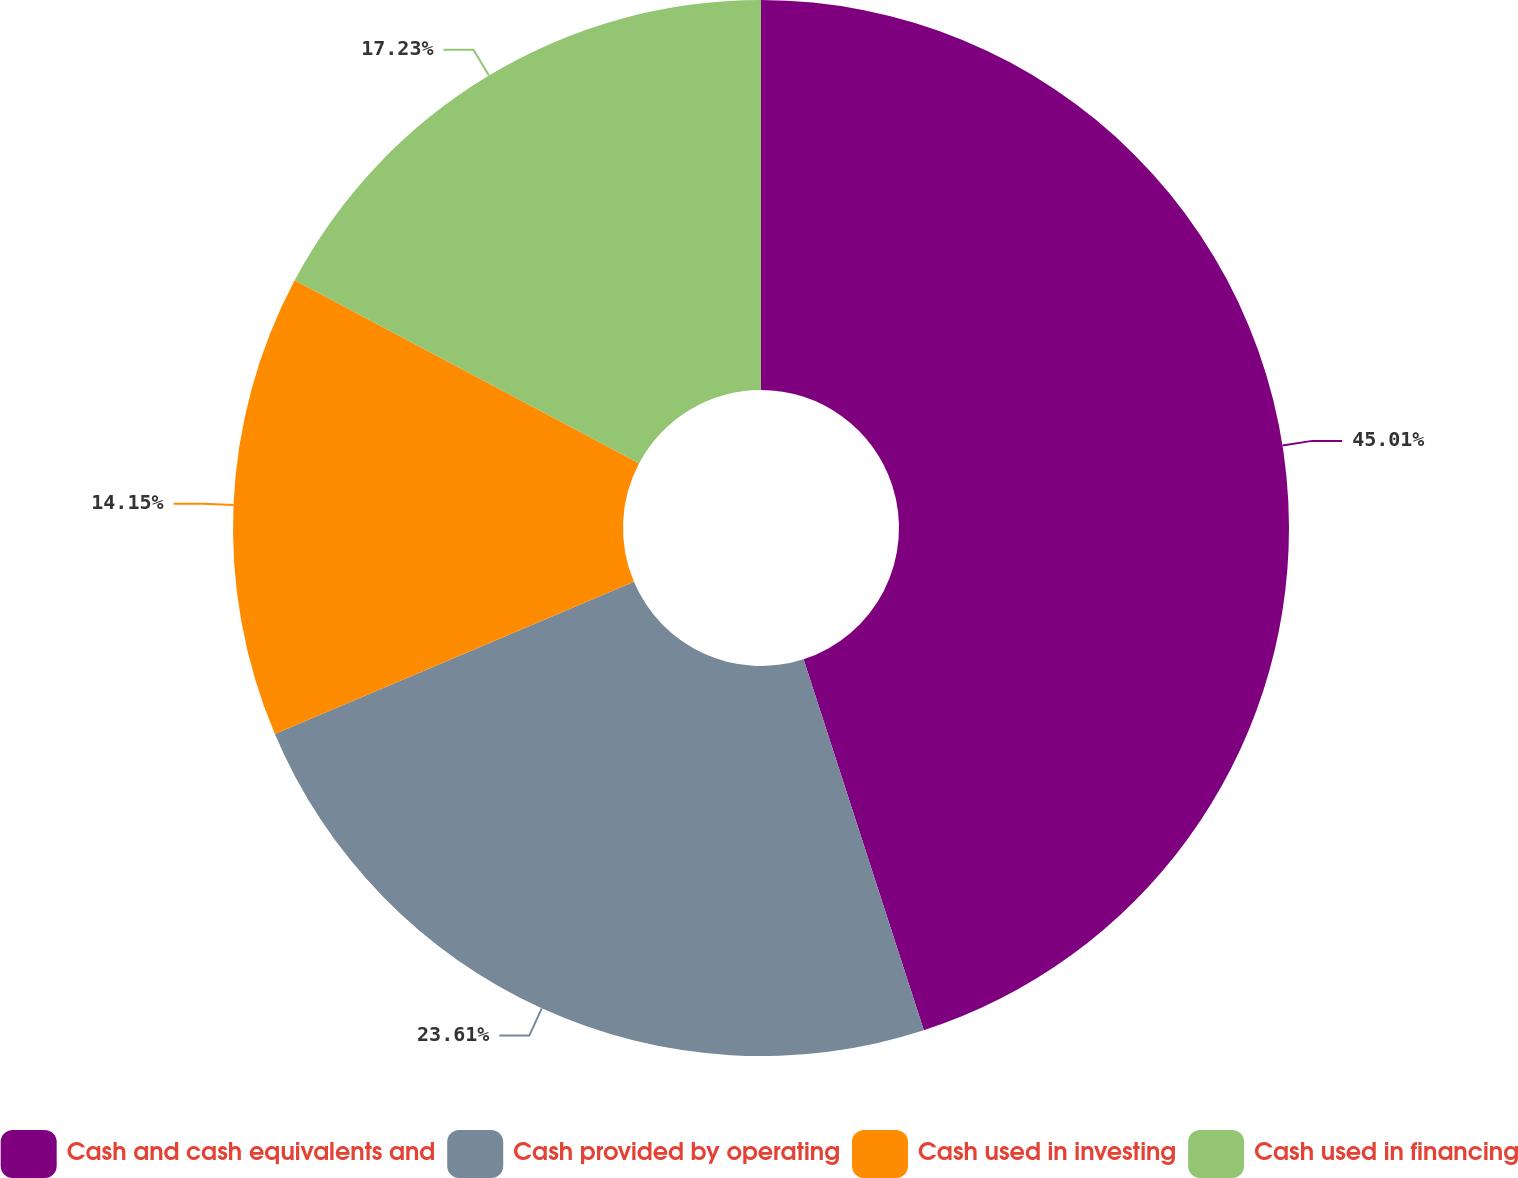Convert chart to OTSL. <chart><loc_0><loc_0><loc_500><loc_500><pie_chart><fcel>Cash and cash equivalents and<fcel>Cash provided by operating<fcel>Cash used in investing<fcel>Cash used in financing<nl><fcel>45.01%<fcel>23.61%<fcel>14.15%<fcel>17.23%<nl></chart> 